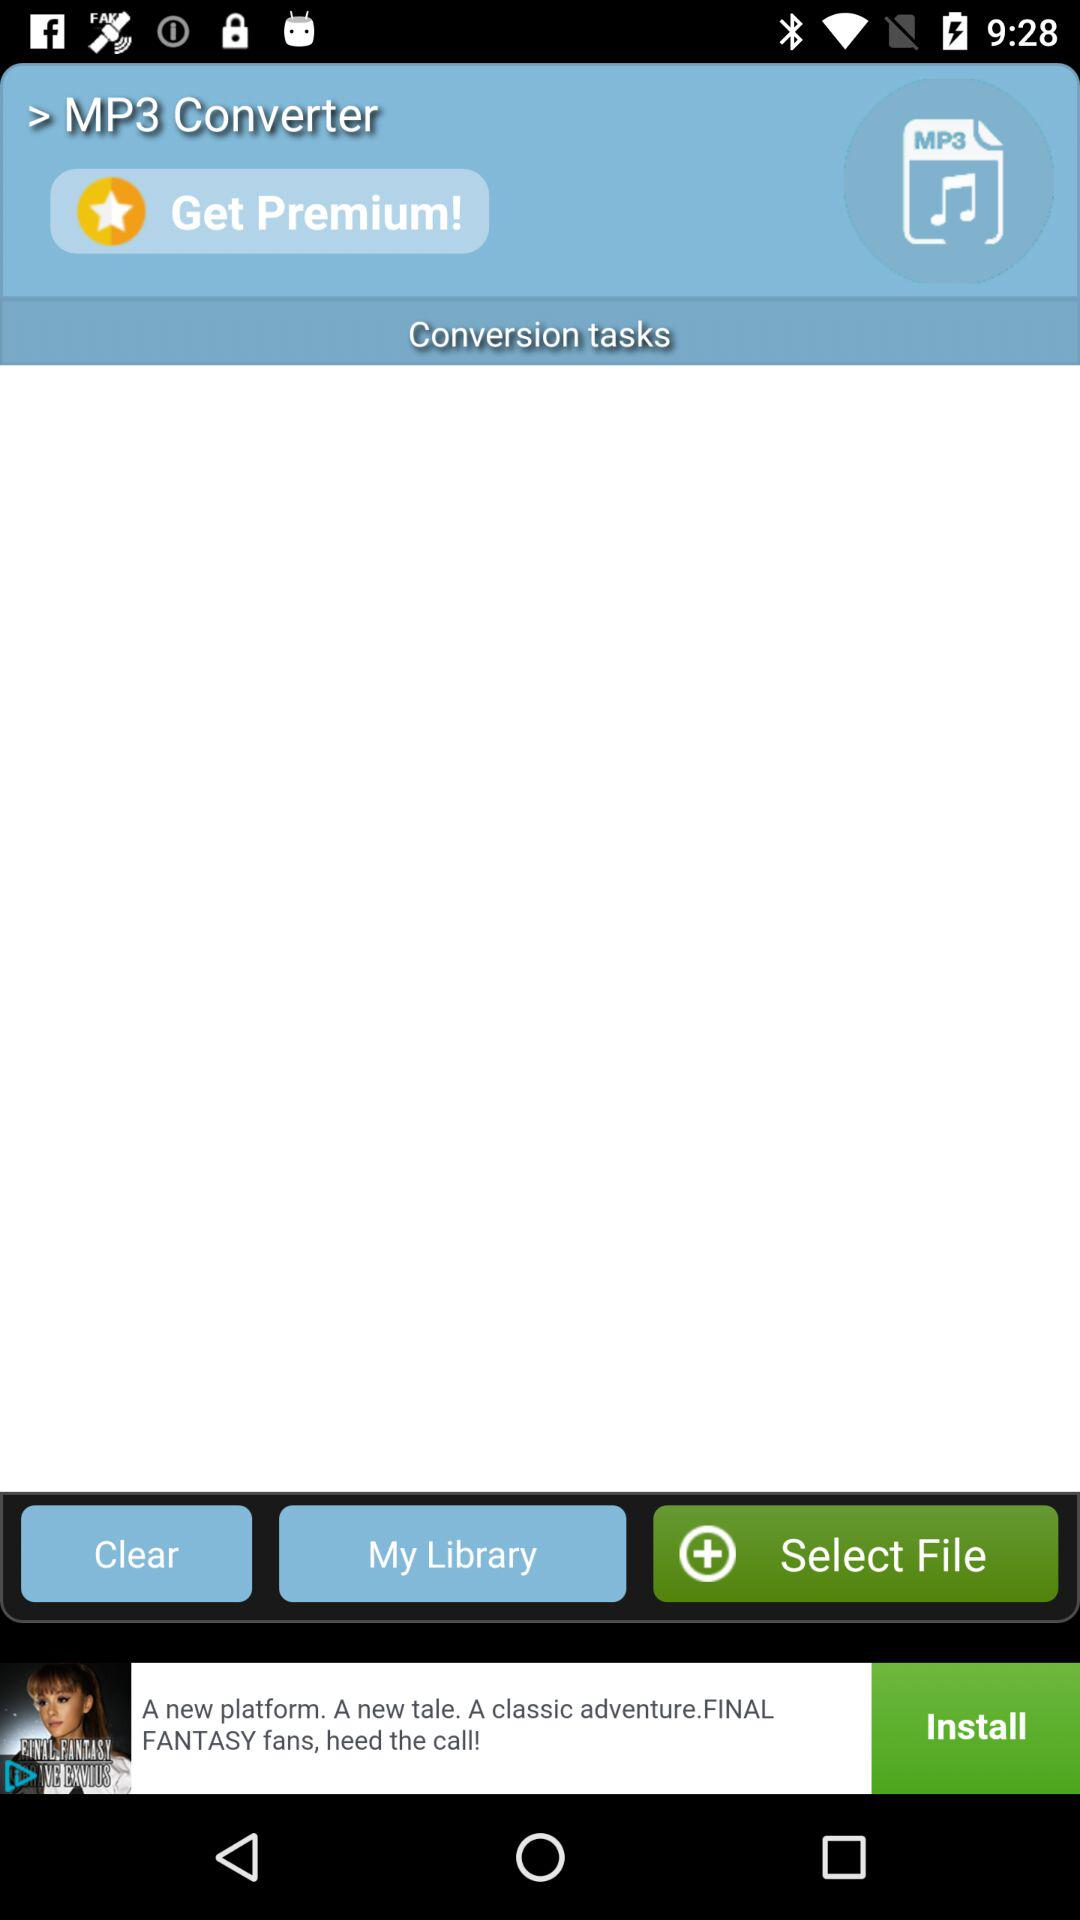What is the app name? The app name is "MP3 Converter". 